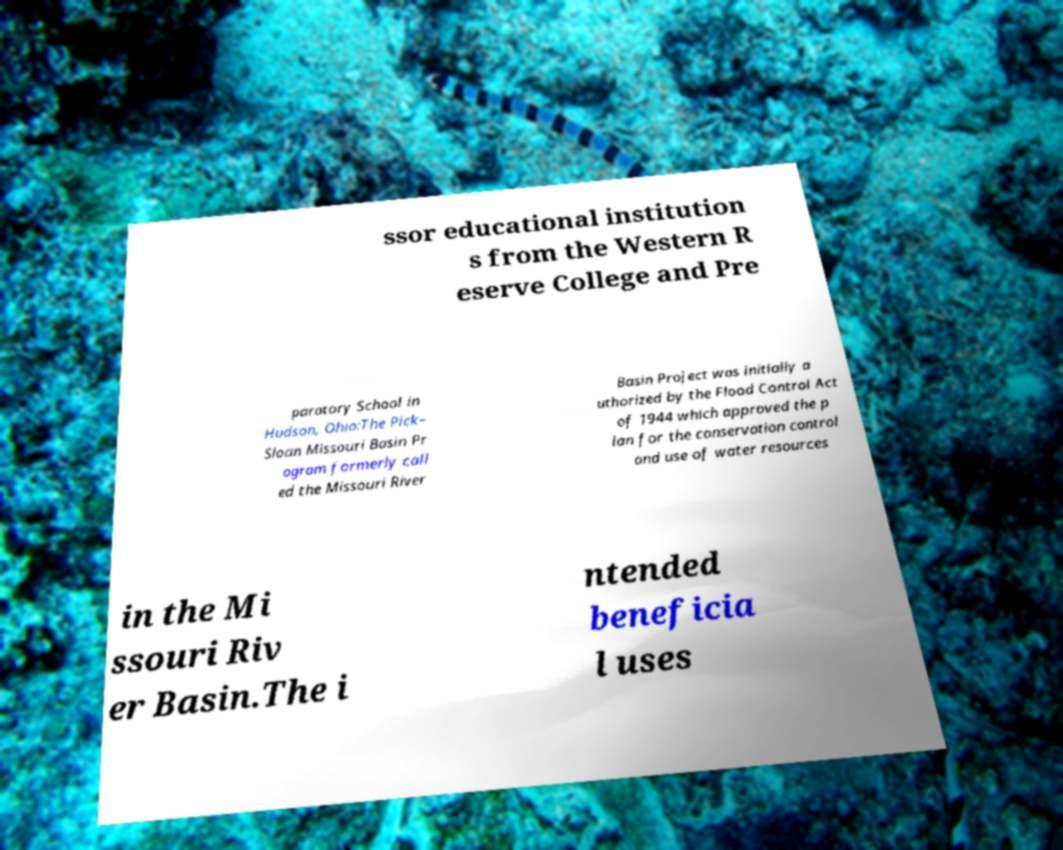For documentation purposes, I need the text within this image transcribed. Could you provide that? ssor educational institution s from the Western R eserve College and Pre paratory School in Hudson, Ohio:The Pick– Sloan Missouri Basin Pr ogram formerly call ed the Missouri River Basin Project was initially a uthorized by the Flood Control Act of 1944 which approved the p lan for the conservation control and use of water resources in the Mi ssouri Riv er Basin.The i ntended beneficia l uses 